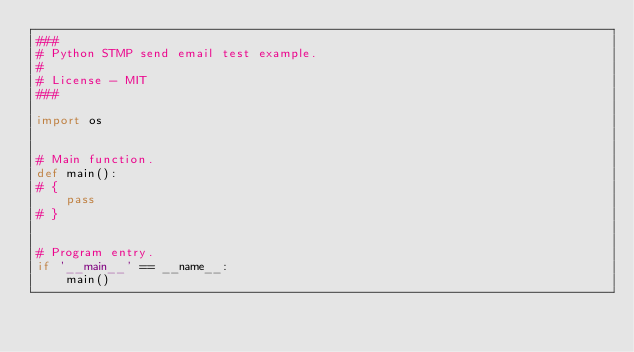Convert code to text. <code><loc_0><loc_0><loc_500><loc_500><_Python_>###
# Python STMP send email test example.
# 
# License - MIT
###

import os


# Main function.
def main():
# {
    pass
# }


# Program entry.
if '__main__' == __name__:
    main()
</code> 